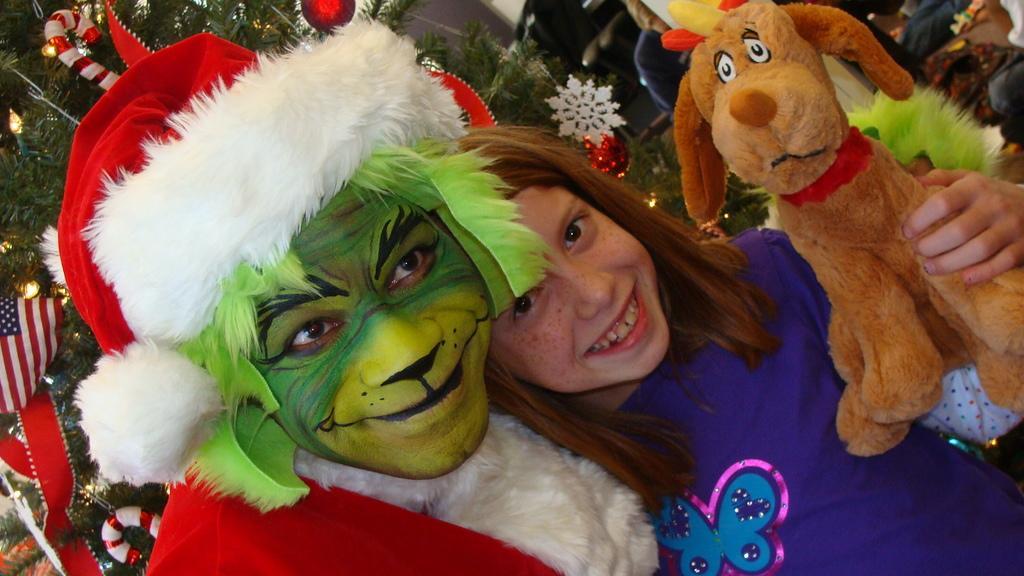Can you describe this image briefly? In this image there is a person in different costume, beside him there is a girl with a smile on her face and she is holding a toy in her hand. In the background there is a Christmas tree. 